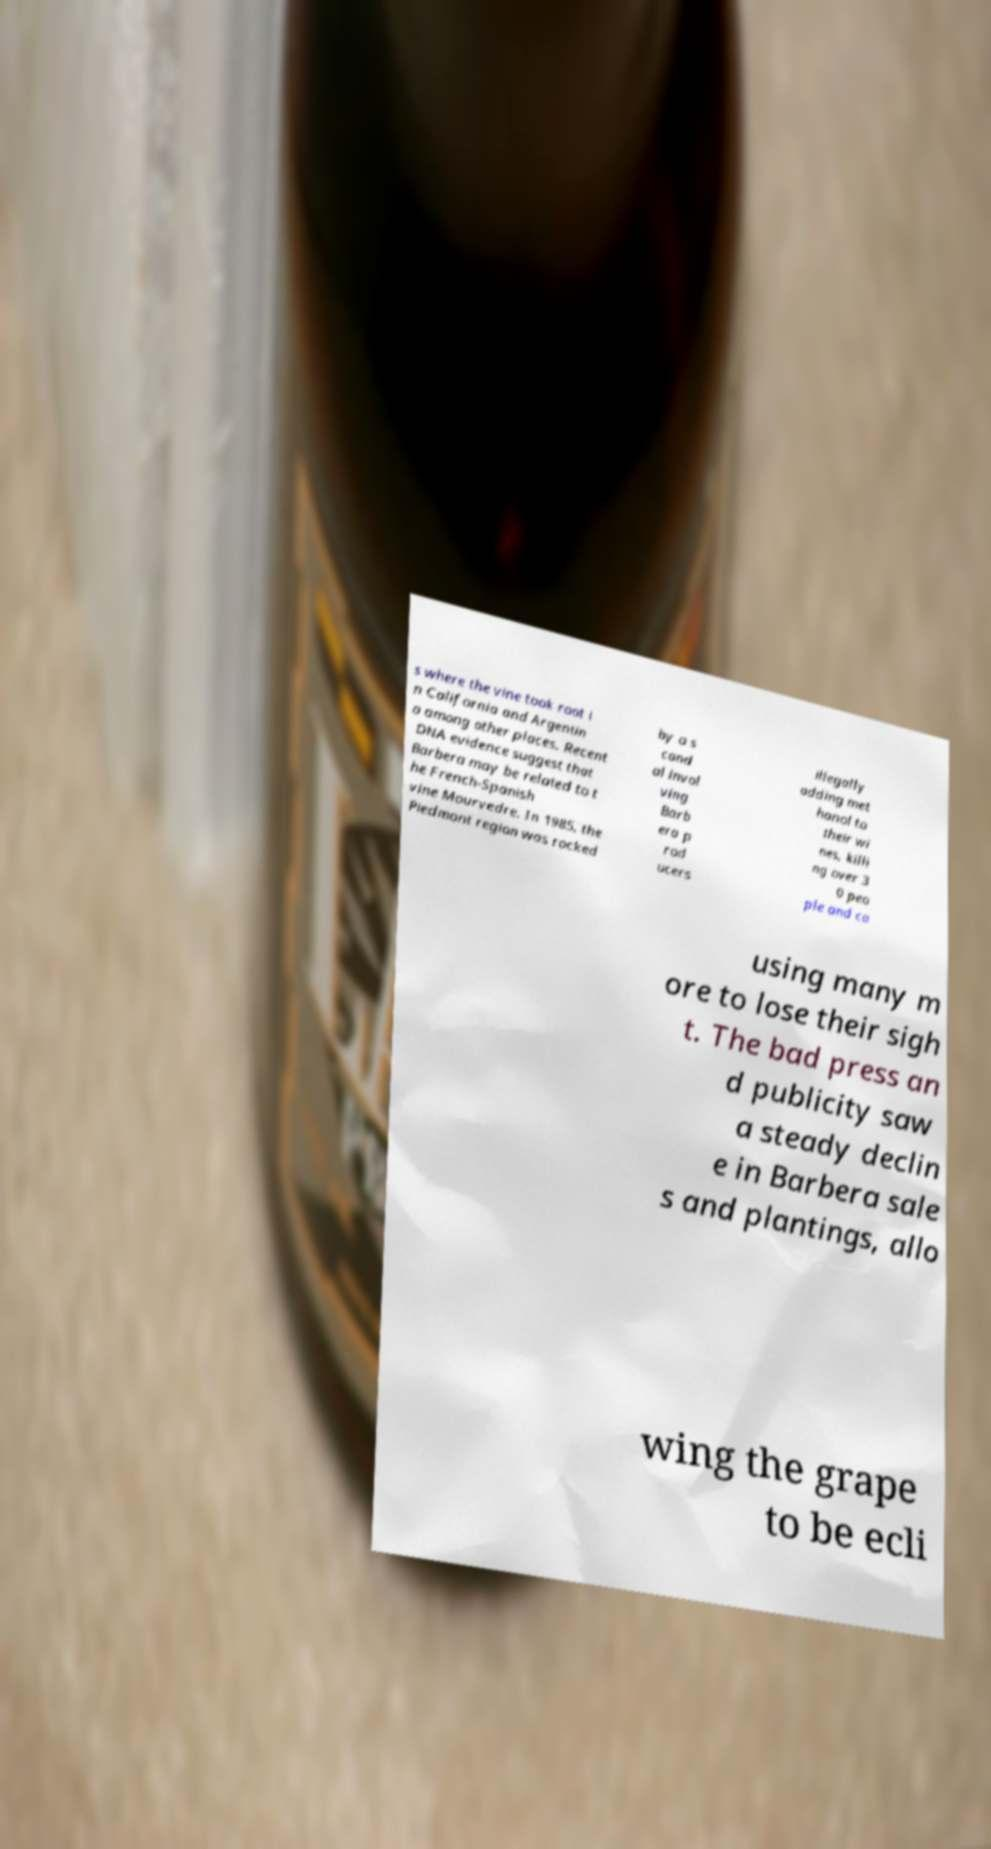Could you extract and type out the text from this image? s where the vine took root i n California and Argentin a among other places. Recent DNA evidence suggest that Barbera may be related to t he French-Spanish vine Mourvedre. In 1985, the Piedmont region was rocked by a s cand al invol ving Barb era p rod ucers illegally adding met hanol to their wi nes, killi ng over 3 0 peo ple and ca using many m ore to lose their sigh t. The bad press an d publicity saw a steady declin e in Barbera sale s and plantings, allo wing the grape to be ecli 